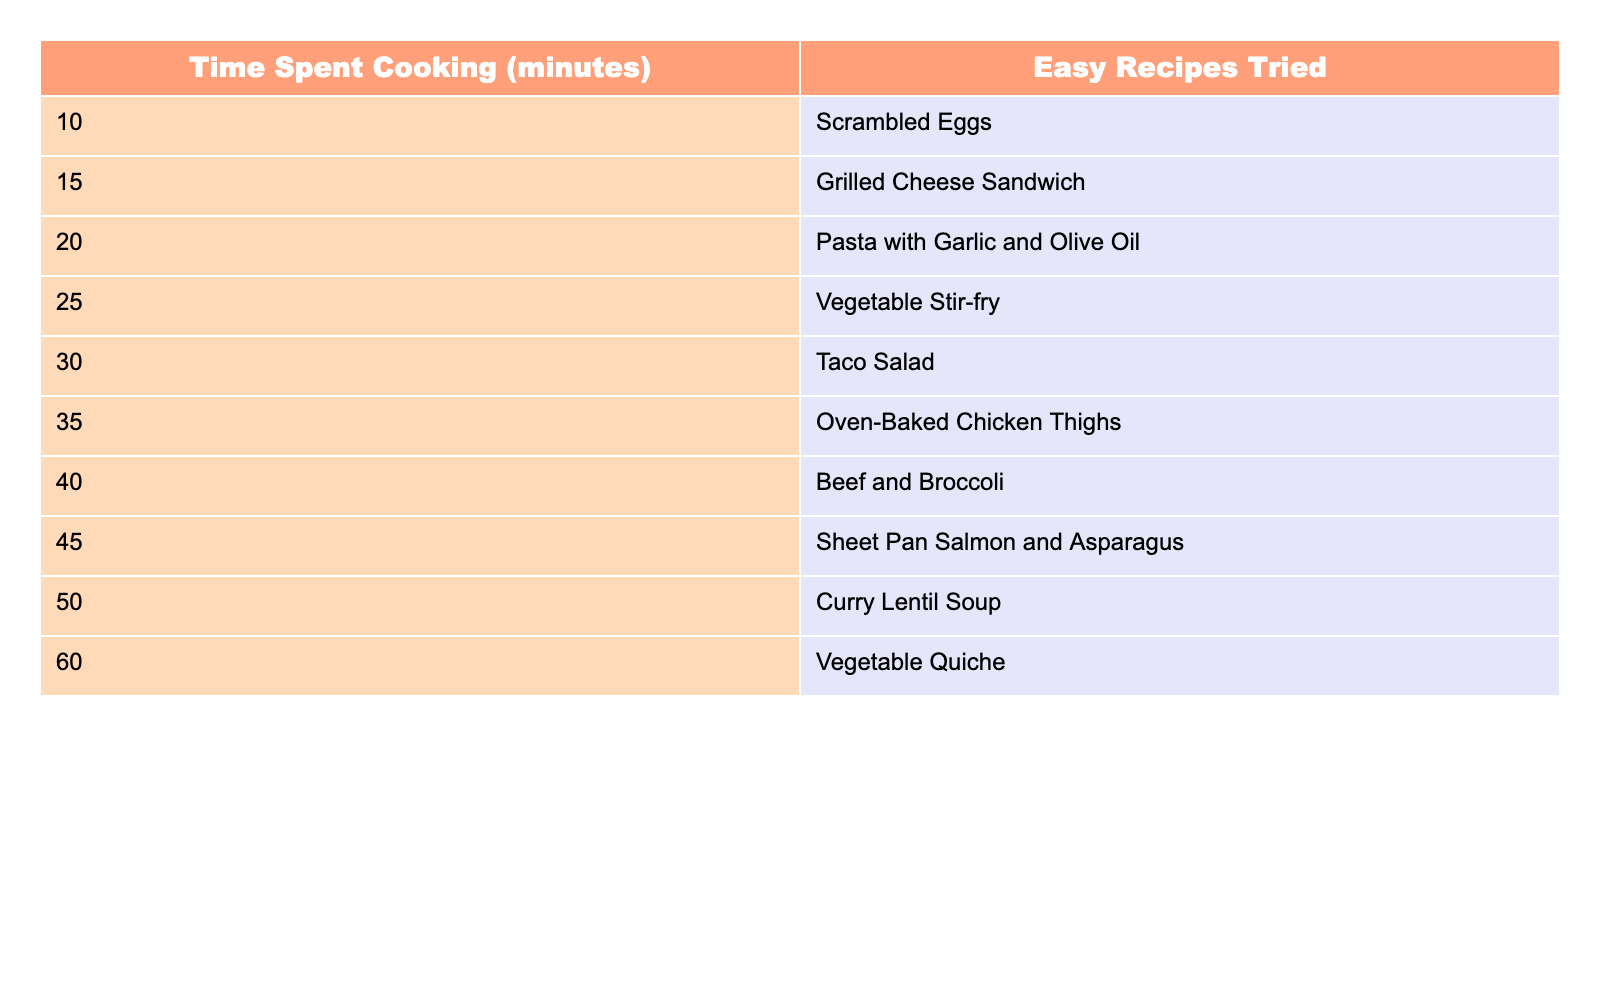What easy recipe requires 25 minutes of cooking? Referring to the table, the recipe listed under 25 minutes is "Vegetable Stir-fry."
Answer: Vegetable Stir-fry How many minutes are needed to try "Curry Lentil Soup"? According to the table, "Curry Lentil Soup" takes 50 minutes to make.
Answer: 50 minutes What is the longest cooking time in this table? The longest cooking time in the table is 60 minutes for "Vegetable Quiche."
Answer: 60 minutes How many easy recipes are tried in less than 30 minutes? The table lists 5 recipes with cooking times less than 30 minutes: "Scrambled Eggs," "Grilled Cheese Sandwich," "Pasta with Garlic and Olive Oil," "Vegetable Stir-fry," and "Taco Salad."
Answer: 5 recipes Is it true that making "Oven-Baked Chicken Thighs" takes more time than "Taco Salad"? "Oven-Baked Chicken Thighs" takes 35 minutes, while "Taco Salad" takes 30 minutes. Therefore, it is true that it takes more time.
Answer: Yes What is the average cooking time for all the easy recipes in the table? Summing the cooking times: 10 + 15 + 20 + 25 + 30 + 35 + 40 + 45 + 50 + 60 = 325 minutes. Dividing by 10 (number of recipes) gives an average of 32.5 minutes.
Answer: 32.5 minutes What is the difference in cooking time between "Beef and Broccoli" and "Sheet Pan Salmon and Asparagus"? "Beef and Broccoli" takes 40 minutes, and "Sheet Pan Salmon and Asparagus" takes 45 minutes. The difference is 5 minutes, calculated as 45 - 40 = 5.
Answer: 5 minutes How many easy recipes are there that take 40 minutes or more? There are 4 recipes that take 40 minutes or more: "Beef and Broccoli," "Sheet Pan Salmon and Asparagus," "Curry Lentil Soup," and "Vegetable Quiche."
Answer: 4 recipes Does making "Pasta with Garlic and Olive Oil" take less time than making "Vegetable Quiche"? "Pasta with Garlic and Olive Oil" takes 20 minutes, while "Vegetable Quiche" takes 60 minutes. So it is true that Pasta takes less time.
Answer: Yes If I wanted to make two recipes that total 70 minutes, which pairs could I choose? The pairs could be "Beef and Broccoli" (40 minutes) & "Oven-Baked Chicken Thighs" (35 minutes), or "Vegetable Stir-fry" (25 minutes) & "Curry Lentil Soup" (50 minutes), totaling to 70 minutes.
Answer: Beef and Broccoli + Oven-Baked Chicken Thighs or Vegetable Stir-fry + Curry Lentil Soup 